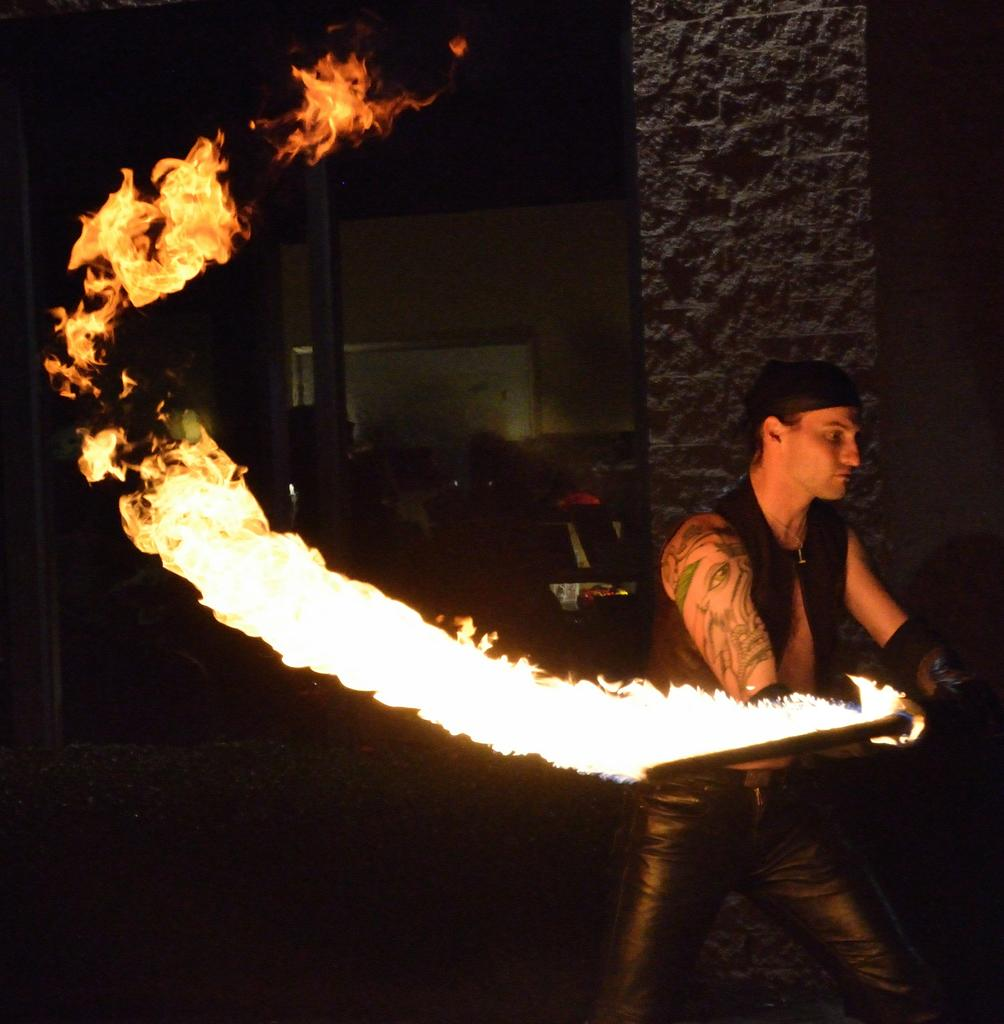Who or what is present in the image? There is a person in the image. What is the person doing in the image? The person is holding an object. Can you describe the flame visible in the image? Yes, there is a flame visible in the image. What can be seen in the background of the image? There is a wall and a board in the background of the image. Are there any objects on the wall? Yes, there are objects on the wall. What type of veil is draped over the board in the image? There is no veil present in the image; it only features a person, an object, a flame, a wall, and objects on the wall. 